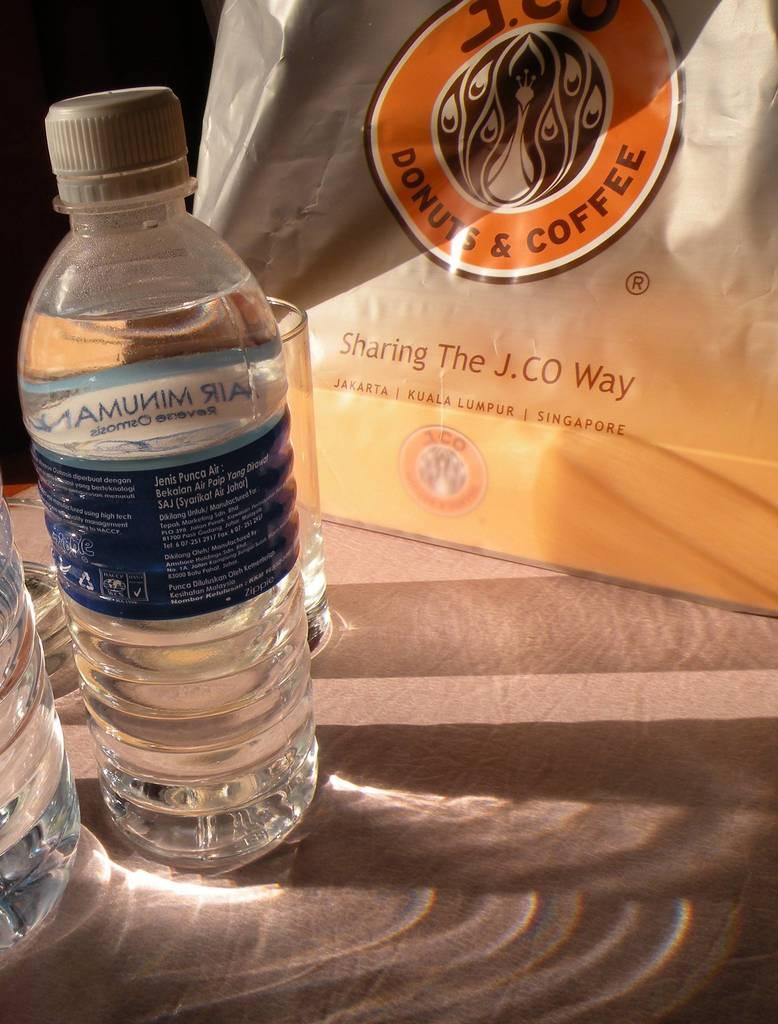What type of food and beverage does the company listed on the bag sell?
Provide a succinct answer. Donuts and coffee. What country is the food from?
Offer a terse response. Singapore. 